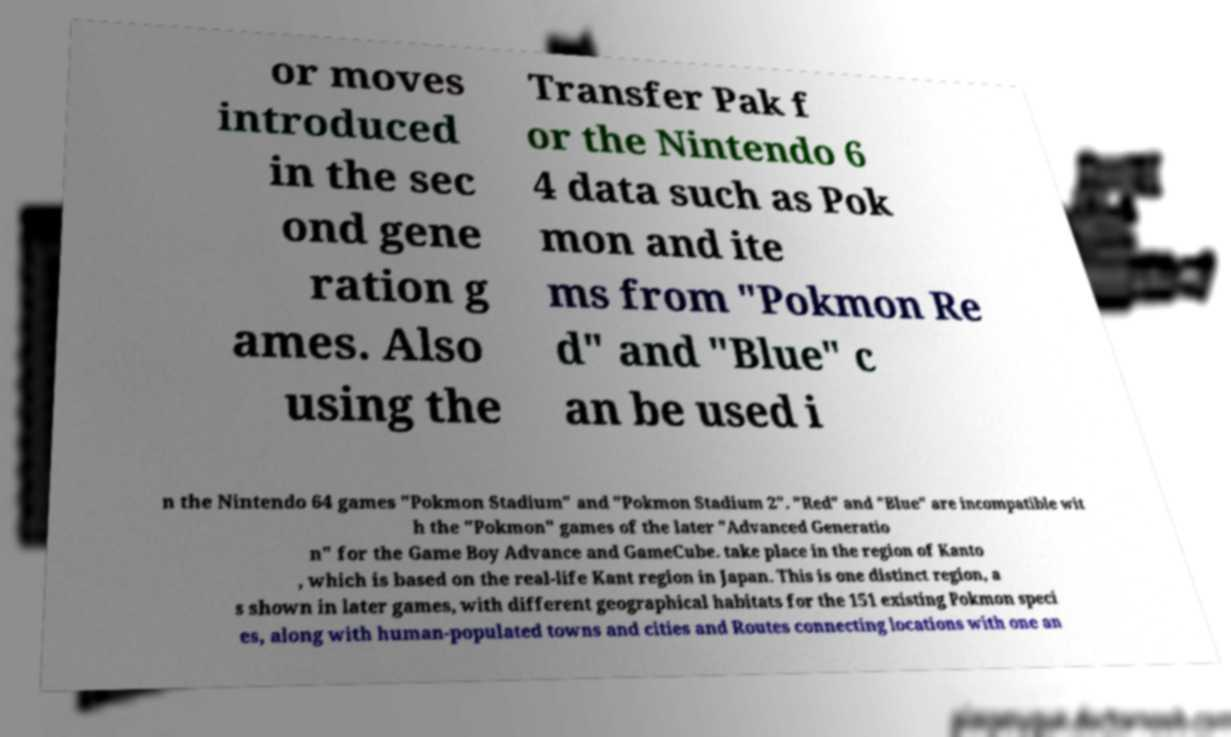Could you extract and type out the text from this image? or moves introduced in the sec ond gene ration g ames. Also using the Transfer Pak f or the Nintendo 6 4 data such as Pok mon and ite ms from "Pokmon Re d" and "Blue" c an be used i n the Nintendo 64 games "Pokmon Stadium" and "Pokmon Stadium 2". "Red" and "Blue" are incompatible wit h the "Pokmon" games of the later "Advanced Generatio n" for the Game Boy Advance and GameCube. take place in the region of Kanto , which is based on the real-life Kant region in Japan. This is one distinct region, a s shown in later games, with different geographical habitats for the 151 existing Pokmon speci es, along with human-populated towns and cities and Routes connecting locations with one an 